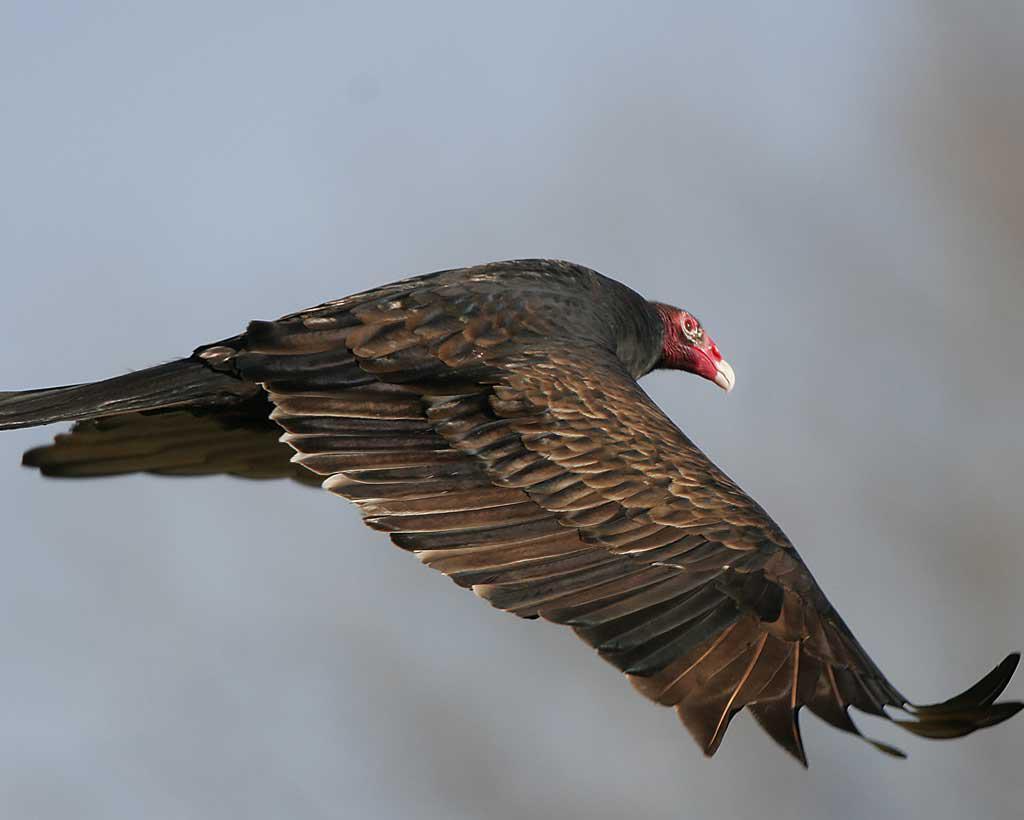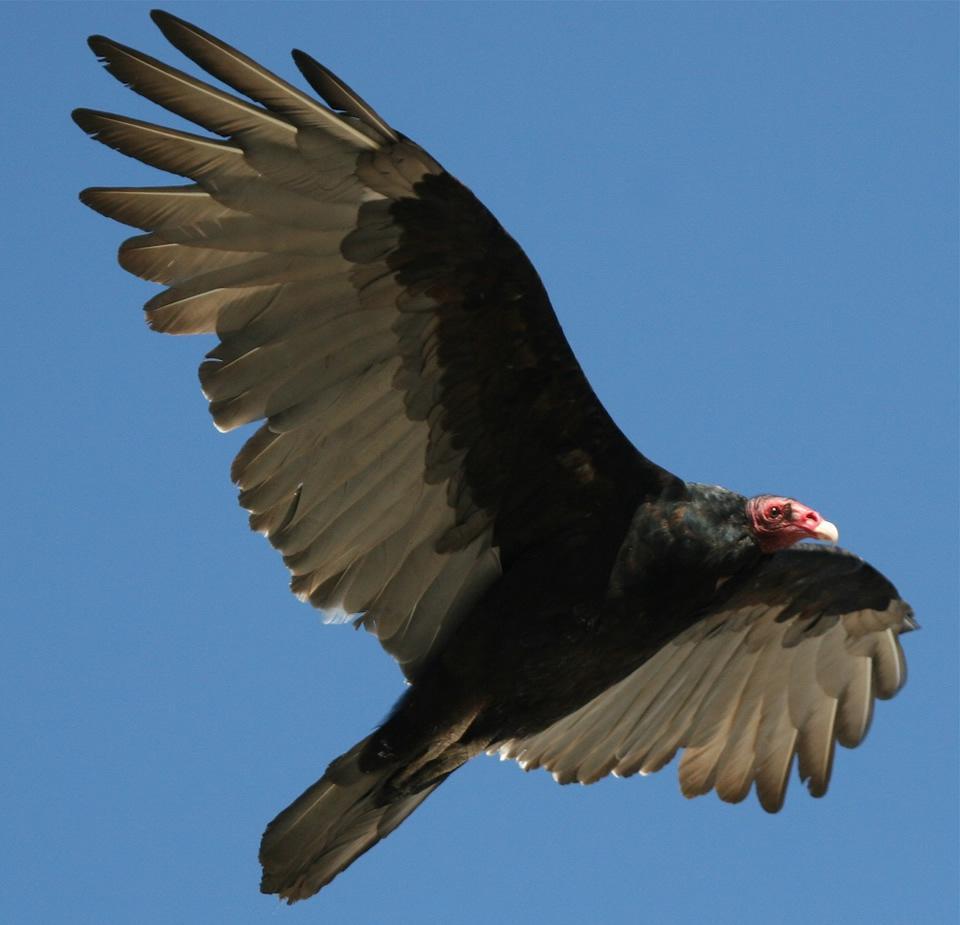The first image is the image on the left, the second image is the image on the right. Given the left and right images, does the statement "There are two vultures flying" hold true? Answer yes or no. Yes. 